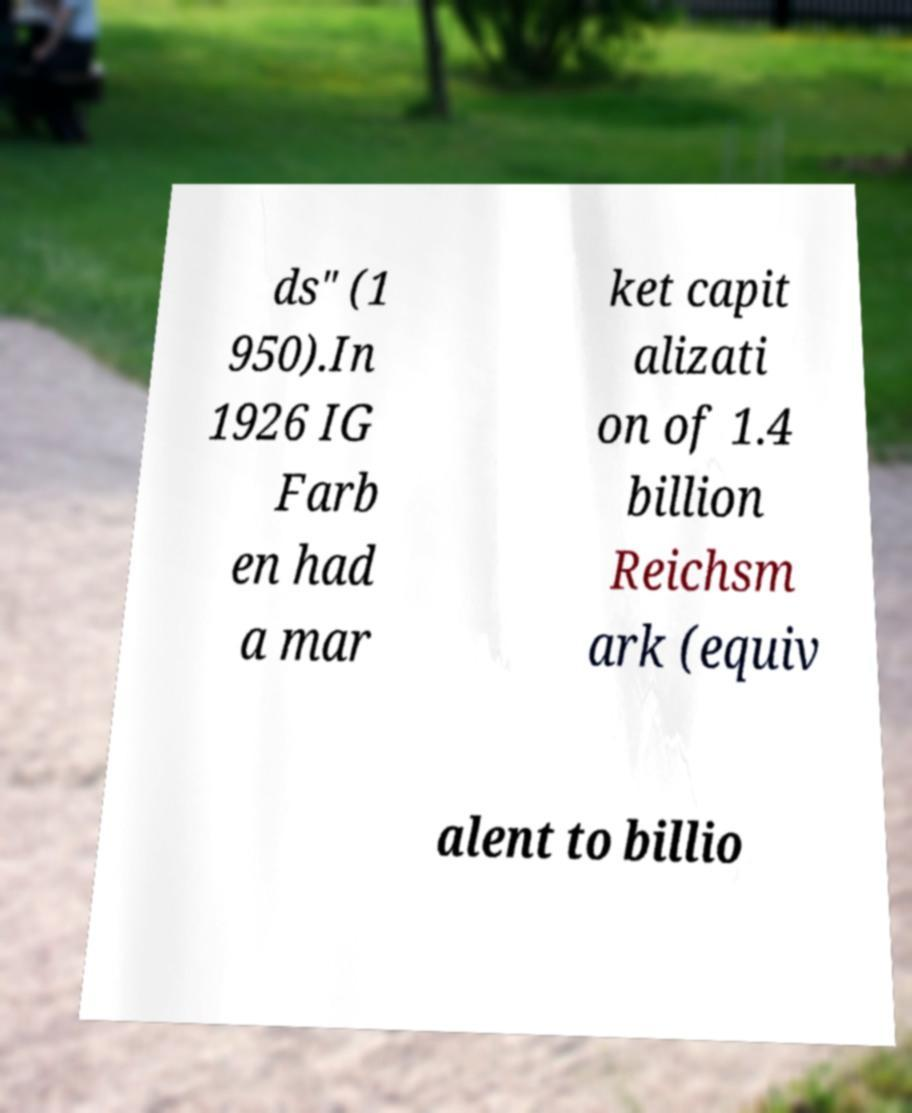I need the written content from this picture converted into text. Can you do that? ds" (1 950).In 1926 IG Farb en had a mar ket capit alizati on of 1.4 billion Reichsm ark (equiv alent to billio 